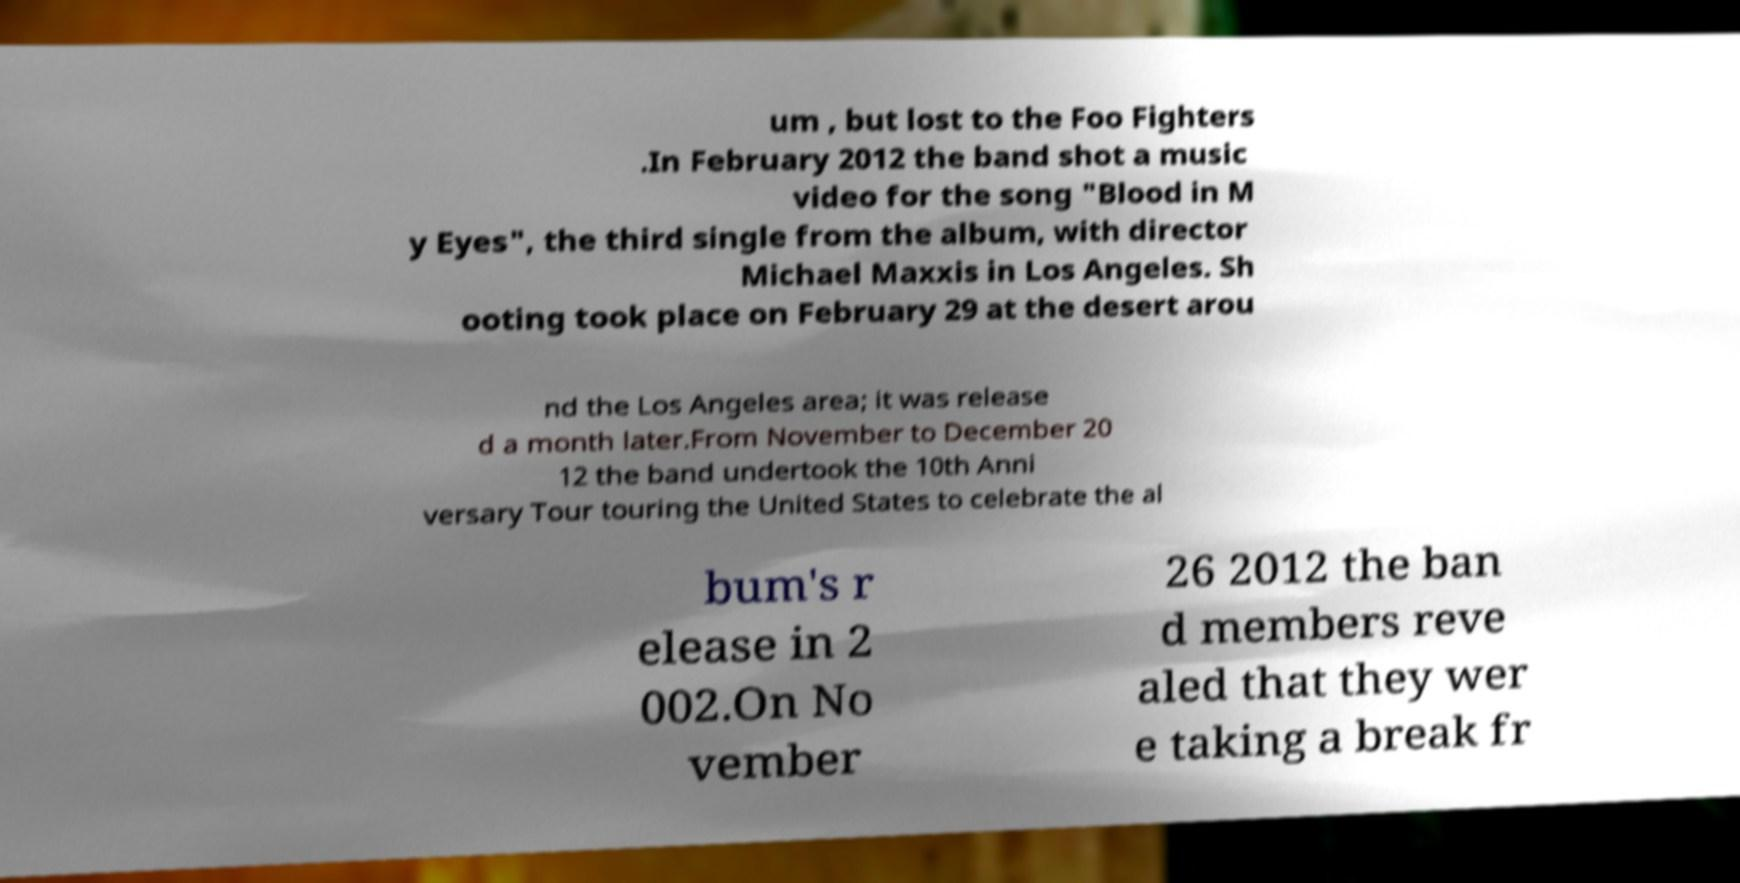Could you extract and type out the text from this image? um , but lost to the Foo Fighters .In February 2012 the band shot a music video for the song "Blood in M y Eyes", the third single from the album, with director Michael Maxxis in Los Angeles. Sh ooting took place on February 29 at the desert arou nd the Los Angeles area; it was release d a month later.From November to December 20 12 the band undertook the 10th Anni versary Tour touring the United States to celebrate the al bum's r elease in 2 002.On No vember 26 2012 the ban d members reve aled that they wer e taking a break fr 